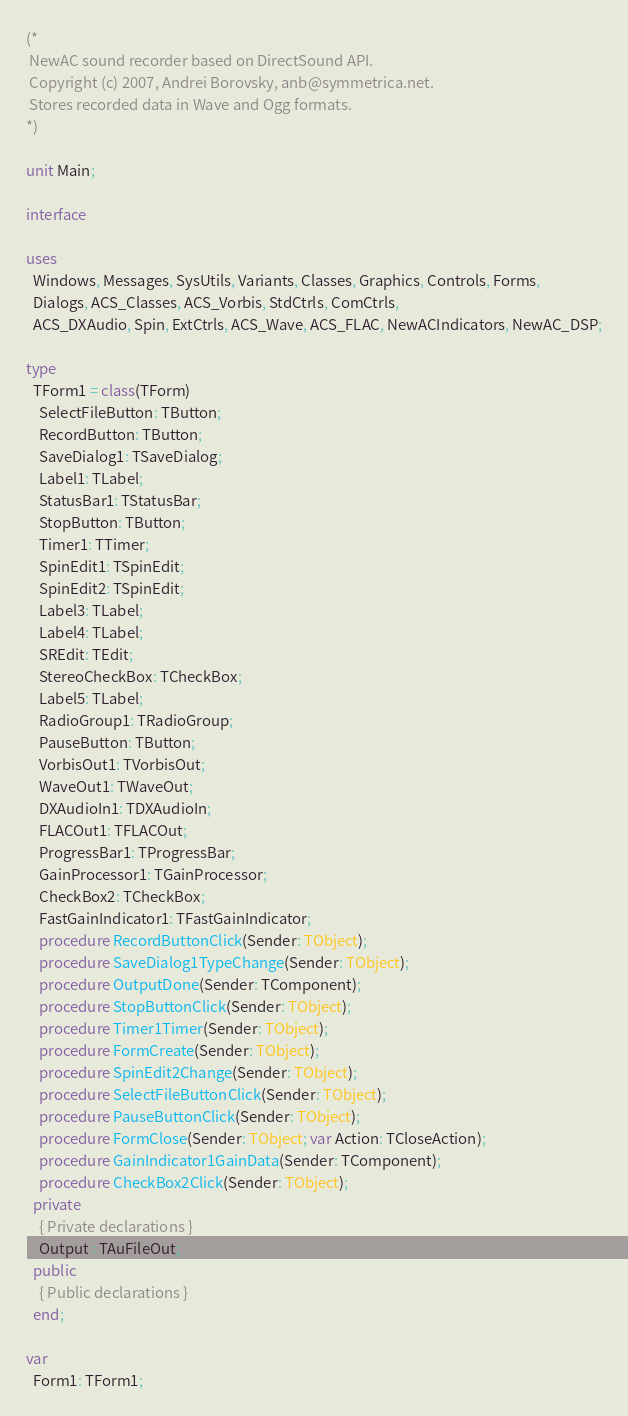Convert code to text. <code><loc_0><loc_0><loc_500><loc_500><_Pascal_>(*
 NewAC sound recorder based on DirectSound API.
 Copyright (c) 2007, Andrei Borovsky, anb@symmetrica.net.
 Stores recorded data in Wave and Ogg formats.
*)

unit Main;

interface

uses
  Windows, Messages, SysUtils, Variants, Classes, Graphics, Controls, Forms,
  Dialogs, ACS_Classes, ACS_Vorbis, StdCtrls, ComCtrls,
  ACS_DXAudio, Spin, ExtCtrls, ACS_Wave, ACS_FLAC, NewACIndicators, NewAC_DSP;

type
  TForm1 = class(TForm)
    SelectFileButton: TButton;
    RecordButton: TButton;
    SaveDialog1: TSaveDialog;
    Label1: TLabel;
    StatusBar1: TStatusBar;
    StopButton: TButton;
    Timer1: TTimer;
    SpinEdit1: TSpinEdit;
    SpinEdit2: TSpinEdit;
    Label3: TLabel;
    Label4: TLabel;
    SREdit: TEdit;
    StereoCheckBox: TCheckBox;
    Label5: TLabel;
    RadioGroup1: TRadioGroup;
    PauseButton: TButton;
    VorbisOut1: TVorbisOut;
    WaveOut1: TWaveOut;
    DXAudioIn1: TDXAudioIn;
    FLACOut1: TFLACOut;
    ProgressBar1: TProgressBar;
    GainProcessor1: TGainProcessor;
    CheckBox2: TCheckBox;
    FastGainIndicator1: TFastGainIndicator;
    procedure RecordButtonClick(Sender: TObject);
    procedure SaveDialog1TypeChange(Sender: TObject);
    procedure OutputDone(Sender: TComponent);
    procedure StopButtonClick(Sender: TObject);
    procedure Timer1Timer(Sender: TObject);
    procedure FormCreate(Sender: TObject);
    procedure SpinEdit2Change(Sender: TObject);
    procedure SelectFileButtonClick(Sender: TObject);
    procedure PauseButtonClick(Sender: TObject);
    procedure FormClose(Sender: TObject; var Action: TCloseAction);
    procedure GainIndicator1GainData(Sender: TComponent);
    procedure CheckBox2Click(Sender: TObject);
  private
    { Private declarations }
    Output : TAuFileOut;
  public
    { Public declarations }
  end;

var
  Form1: TForm1;</code> 